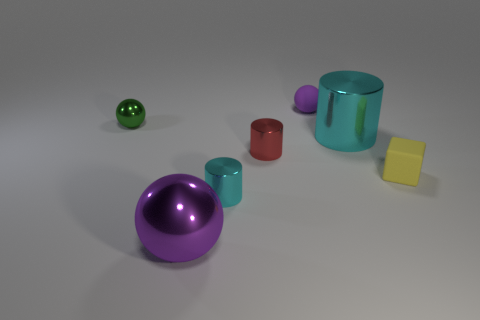What is the material of the tiny ball that is the same color as the large metallic sphere? While I can't physically examine the objects, the small ball with the same color as the large metallic sphere likely mimics the material appearance of polished metal. However, considering its size and typical material use in similar visual representations, it could also be a small rubber ball that's been colored to give it a metallic look. 